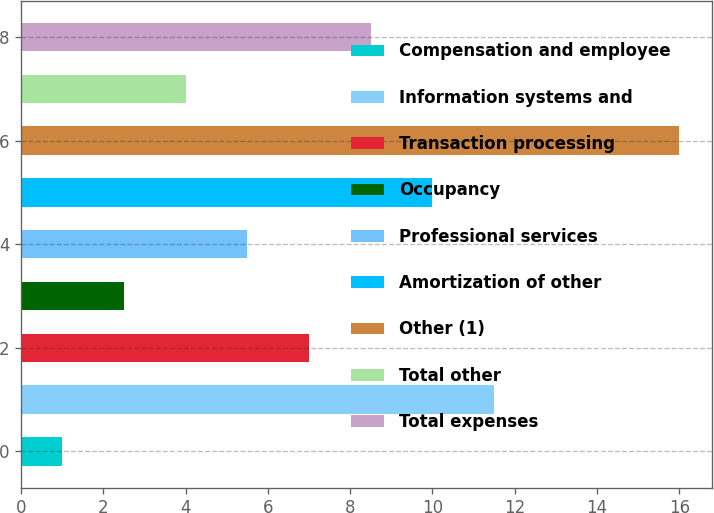Convert chart. <chart><loc_0><loc_0><loc_500><loc_500><bar_chart><fcel>Compensation and employee<fcel>Information systems and<fcel>Transaction processing<fcel>Occupancy<fcel>Professional services<fcel>Amortization of other<fcel>Other (1)<fcel>Total other<fcel>Total expenses<nl><fcel>1<fcel>11.5<fcel>7<fcel>2.5<fcel>5.5<fcel>10<fcel>16<fcel>4<fcel>8.5<nl></chart> 